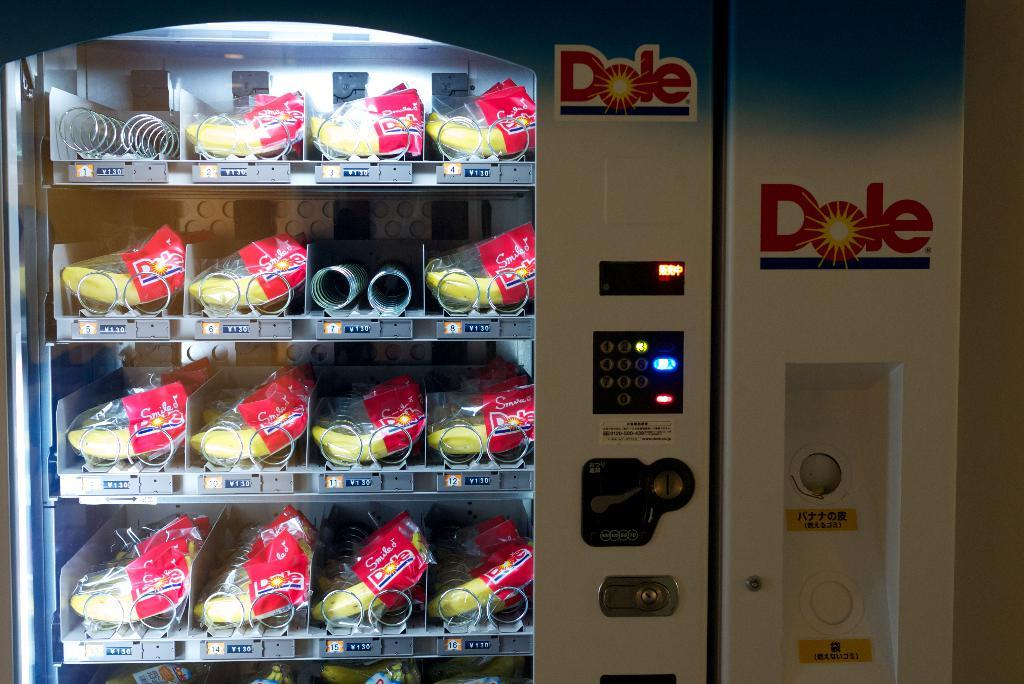<image>
Render a clear and concise summary of the photo. Fruit can be purchased from this Dole vending machine. 